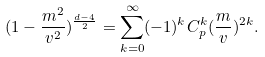Convert formula to latex. <formula><loc_0><loc_0><loc_500><loc_500>( 1 - \frac { m ^ { 2 } } { v ^ { 2 } } ) ^ { \frac { d - 4 } { 2 } } = \sum _ { k = 0 } ^ { \infty } ( - 1 ) ^ { k } C _ { p } ^ { k } ( \frac { m } { v } ) ^ { 2 k } .</formula> 